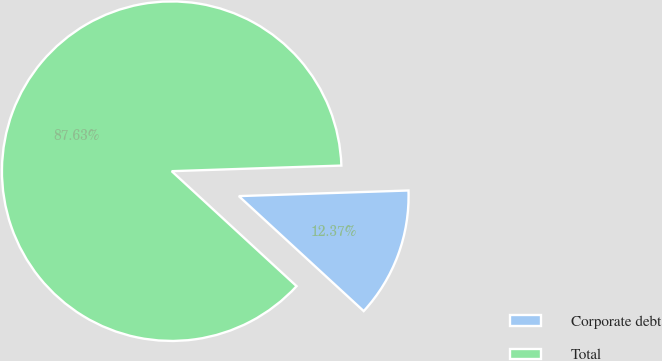Convert chart. <chart><loc_0><loc_0><loc_500><loc_500><pie_chart><fcel>Corporate debt<fcel>Total<nl><fcel>12.37%<fcel>87.63%<nl></chart> 